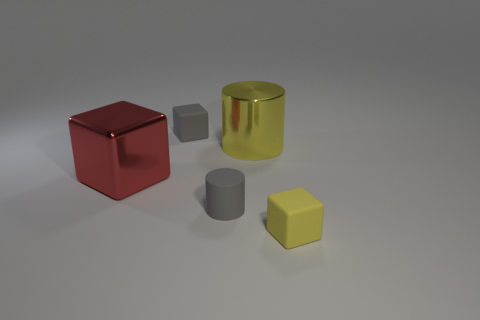Is there any other thing that is the same shape as the large yellow metal thing?
Ensure brevity in your answer.  Yes. Are the cylinder left of the yellow metallic cylinder and the red block made of the same material?
Offer a terse response. No. What material is the yellow thing that is the same size as the gray rubber cylinder?
Make the answer very short. Rubber. How many other objects are there of the same material as the red cube?
Ensure brevity in your answer.  1. There is a gray matte block; is it the same size as the object that is to the right of the large yellow metal cylinder?
Make the answer very short. Yes. Are there fewer big cylinders to the left of the tiny gray matte cube than small yellow blocks left of the big yellow shiny cylinder?
Give a very brief answer. No. There is a matte block left of the yellow matte thing; what is its size?
Keep it short and to the point. Small. Do the yellow metallic thing and the red object have the same size?
Keep it short and to the point. Yes. How many objects are in front of the big red metal block and to the left of the yellow matte cube?
Keep it short and to the point. 1. How many green things are cylinders or large metallic objects?
Give a very brief answer. 0. 